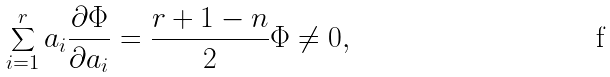Convert formula to latex. <formula><loc_0><loc_0><loc_500><loc_500>\sum _ { i = 1 } ^ { r } a _ { i } \frac { \partial \Phi } { \partial a _ { i } } = \frac { r + 1 - n } { 2 } \Phi \neq 0 ,</formula> 